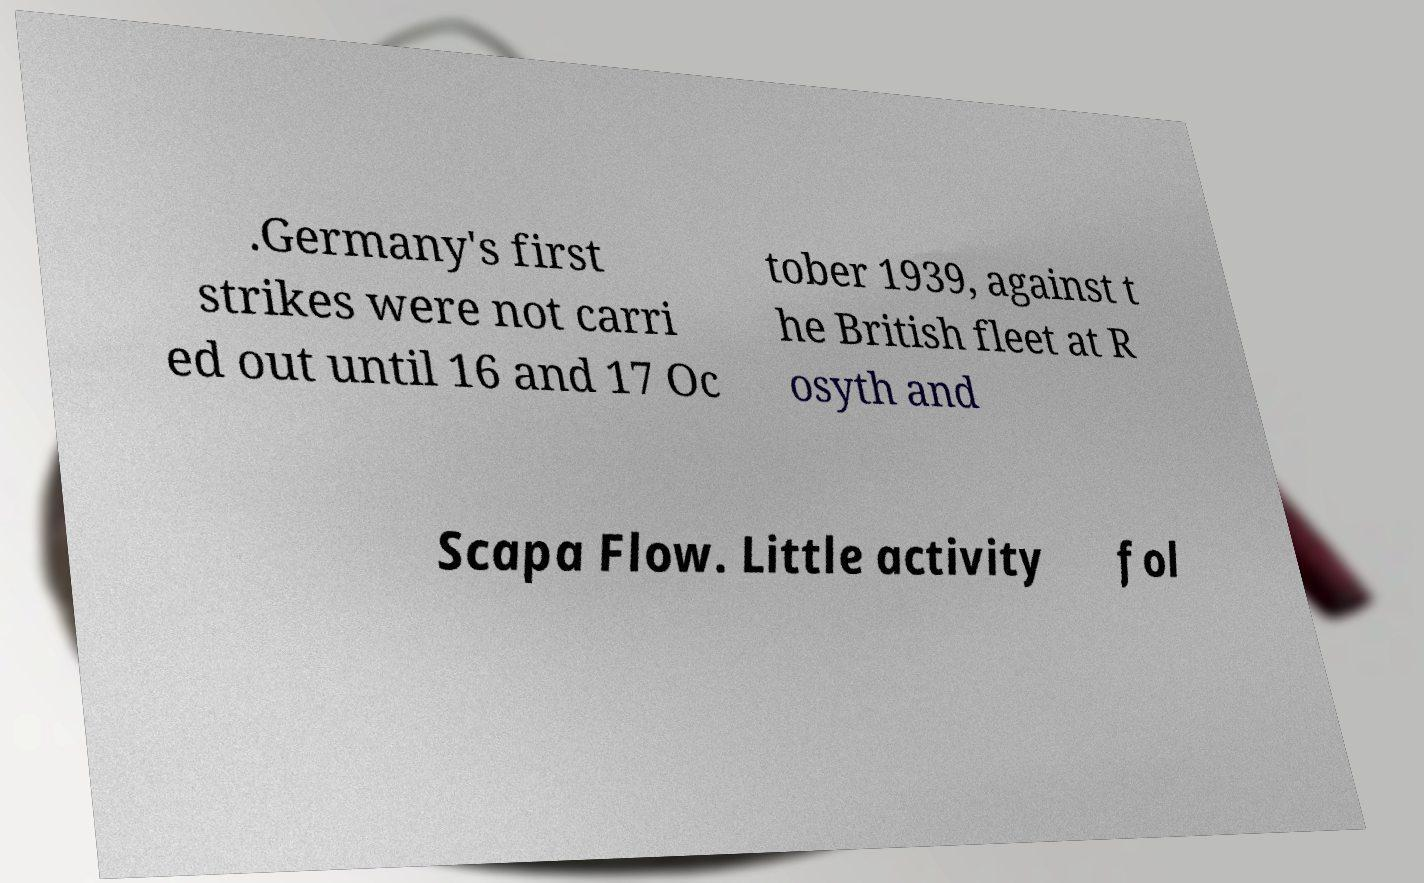Please identify and transcribe the text found in this image. .Germany's first strikes were not carri ed out until 16 and 17 Oc tober 1939, against t he British fleet at R osyth and Scapa Flow. Little activity fol 